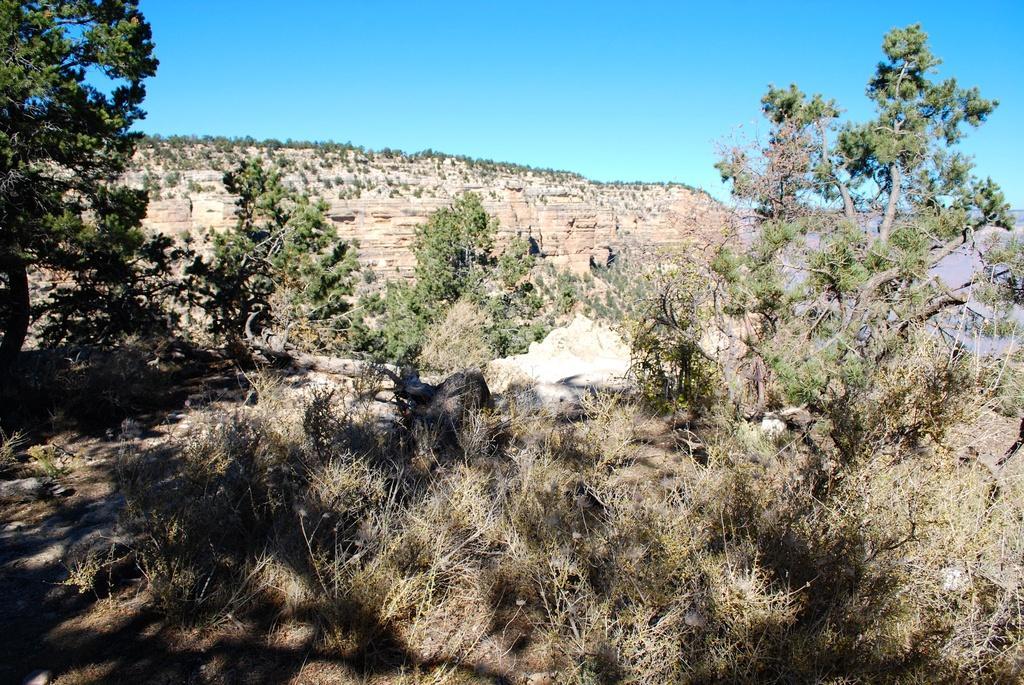Please provide a concise description of this image. At the bottom of the picture, we see trees and plants. There are trees and hills in the background. At the top of the picture, we see the sky, which is blue in color. 